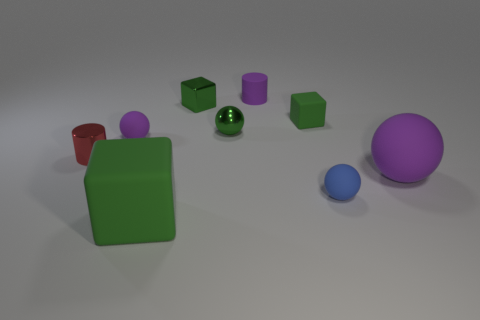How many green blocks must be subtracted to get 1 green blocks? 2 Add 1 small shiny balls. How many objects exist? 10 Subtract all cubes. How many objects are left? 6 Subtract 0 cyan cylinders. How many objects are left? 9 Subtract all purple objects. Subtract all blue balls. How many objects are left? 5 Add 3 small purple rubber things. How many small purple rubber things are left? 5 Add 3 purple matte spheres. How many purple matte spheres exist? 5 